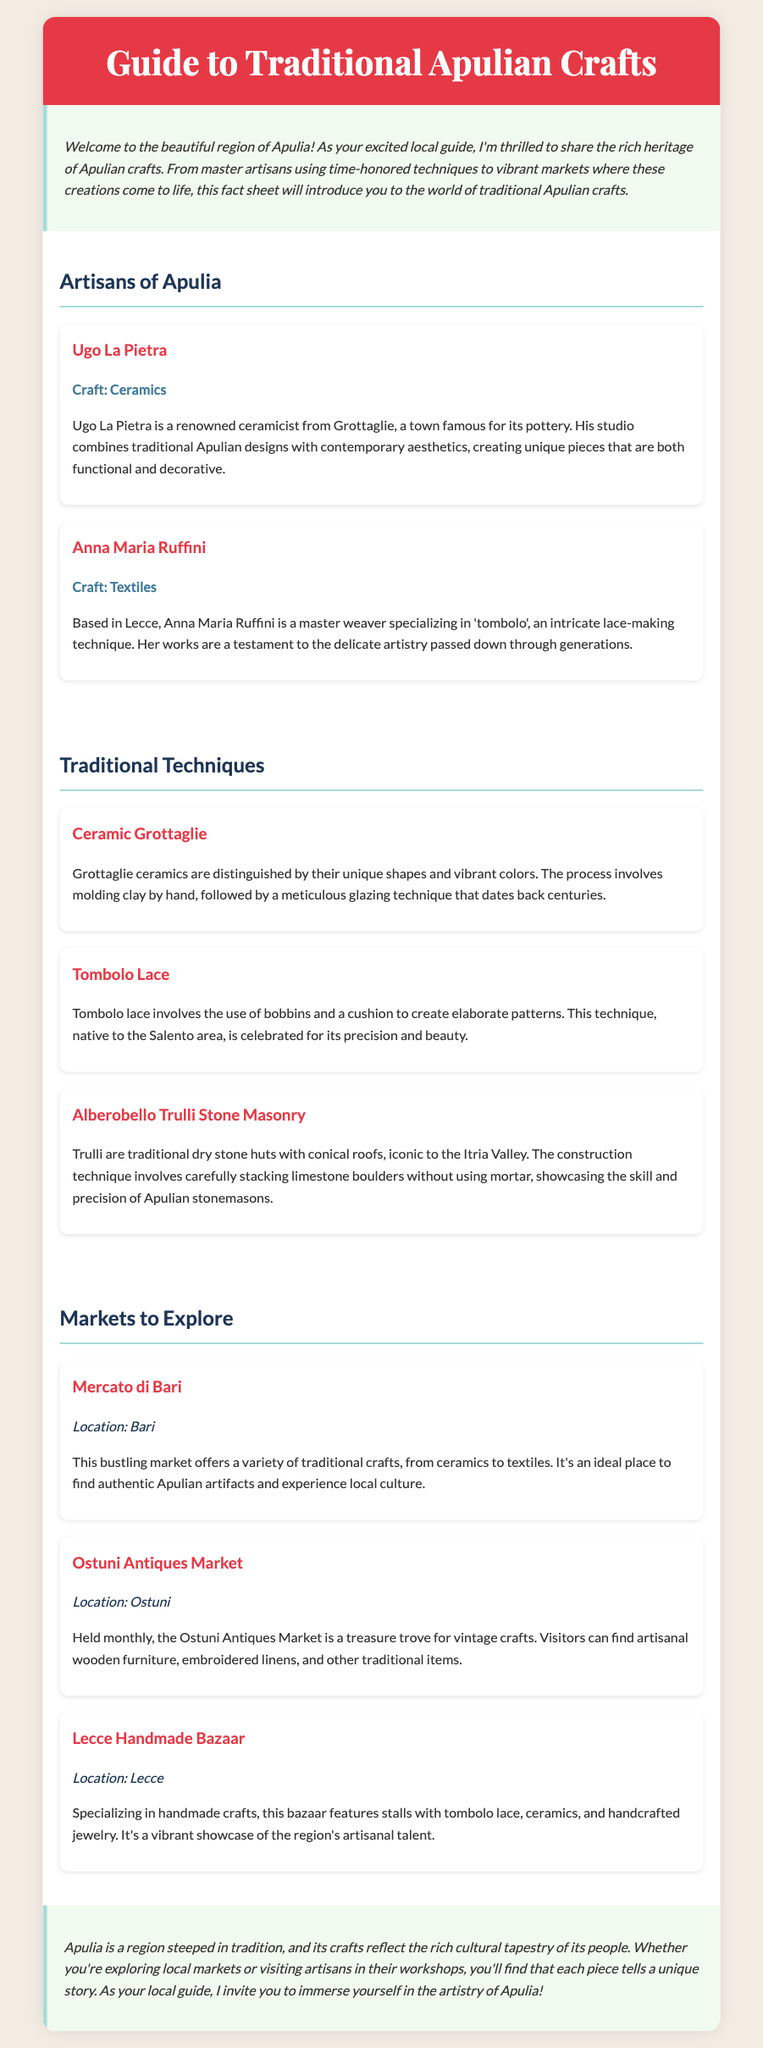What is the name of the master weaver? The document states that Anna Maria Ruffini is a master weaver specializing in 'tombolo'.
Answer: Anna Maria Ruffini What craft does Ugo La Pietra specialize in? According to the document, Ugo La Pietra is a renowned ceramicist, indicating his craft is ceramics.
Answer: Ceramics Where is the Mercato di Bari located? The document specifies that the Mercato di Bari is located in Bari.
Answer: Bari What traditional technique is celebrated for its precision and beauty? The document mentions that Tombolo lace is celebrated for its precision and beauty.
Answer: Tombolo lace How often is the Ostuni Antiques Market held? The document states that the Ostuni Antiques Market is held monthly.
Answer: Monthly Which town is famous for ceramics? The document indicates that Grottaglie is a town famous for its pottery.
Answer: Grottaglie What type of items can you find at the Lecce Handmade Bazaar? The document lists items such as tombolo lace, ceramics, and handcrafted jewelry at the Lecce Handmade Bazaar.
Answer: Tombolo lace, ceramics, and handcrafted jewelry What is unique about Grottaglie ceramics? The document mentions that Grottaglie ceramics are distinguished by their unique shapes and vibrant colors.
Answer: Unique shapes and vibrant colors What architectural structure is iconic to the Itria Valley? The document states that Trulli are traditional dry stone huts with conical roofs that are iconic to the Itria Valley.
Answer: Trulli 